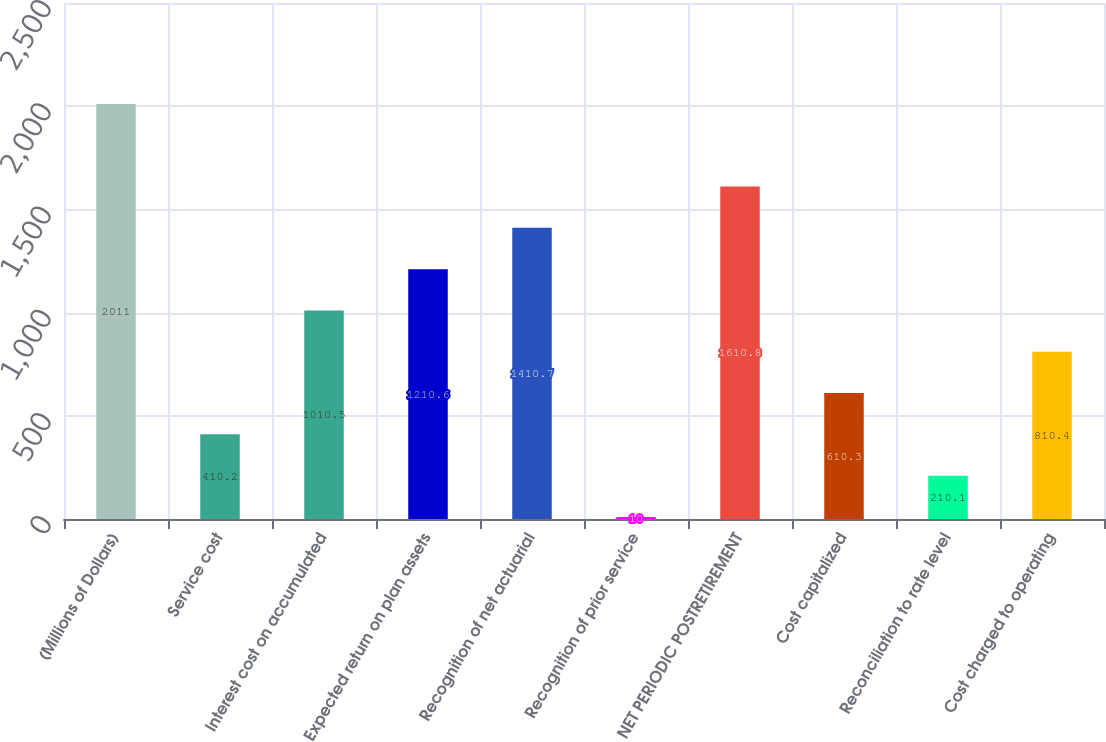<chart> <loc_0><loc_0><loc_500><loc_500><bar_chart><fcel>(Millions of Dollars)<fcel>Service cost<fcel>Interest cost on accumulated<fcel>Expected return on plan assets<fcel>Recognition of net actuarial<fcel>Recognition of prior service<fcel>NET PERIODIC POSTRETIREMENT<fcel>Cost capitalized<fcel>Reconciliation to rate level<fcel>Cost charged to operating<nl><fcel>2011<fcel>410.2<fcel>1010.5<fcel>1210.6<fcel>1410.7<fcel>10<fcel>1610.8<fcel>610.3<fcel>210.1<fcel>810.4<nl></chart> 